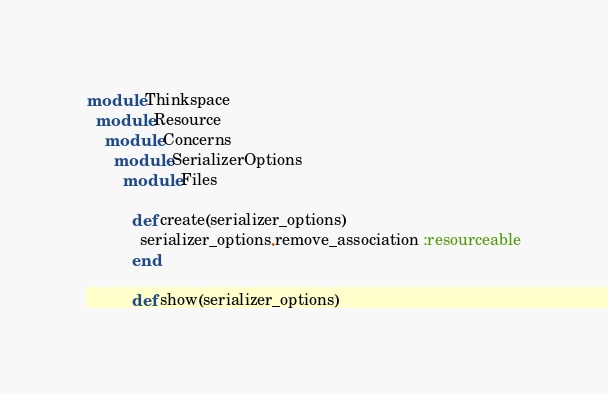<code> <loc_0><loc_0><loc_500><loc_500><_Ruby_>module Thinkspace
  module Resource
    module Concerns
      module SerializerOptions
        module Files

          def create(serializer_options)
            serializer_options.remove_association :resourceable
          end

          def show(serializer_options)</code> 